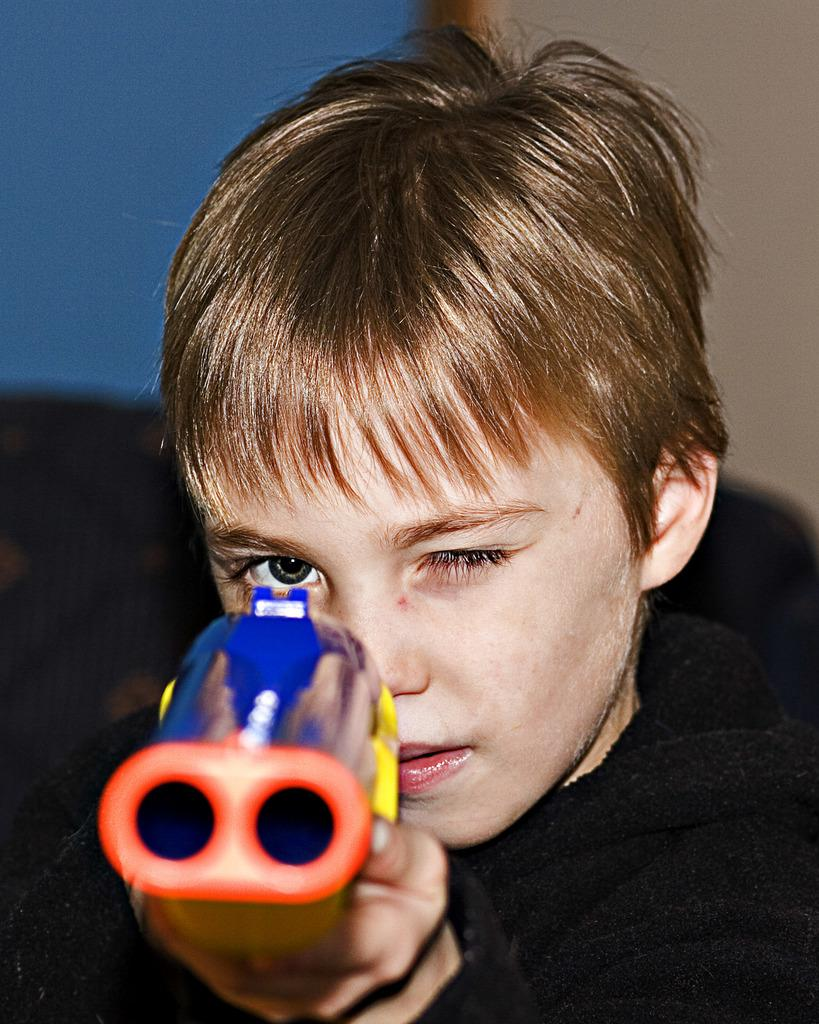Who is the main subject in the picture? The main subject in the picture is a boy. What is the boy holding in the picture? The boy is holding a gun in the picture. Can you describe the boy's facial expression? The boy has closed one of his eyes in the picture. What color is the shirt the boy is wearing? The boy is wearing a black color shirt in the picture. What type of mass is being held at night in the image? There is no mass or nighttime event depicted in the image; it features a boy holding a gun. Who is the manager of the event in the image? There is no event or manager present in the image. 